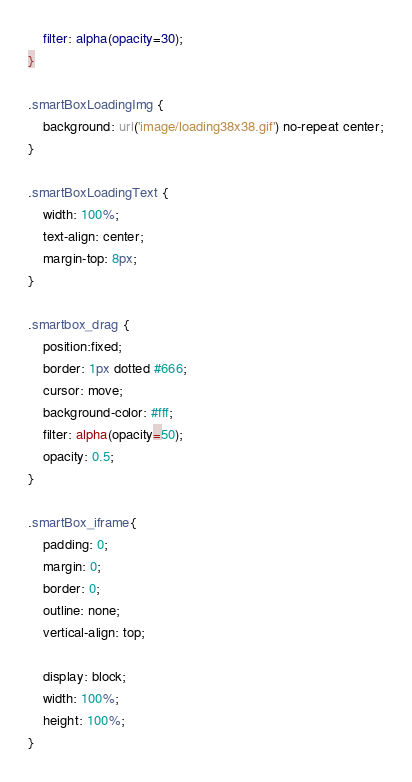<code> <loc_0><loc_0><loc_500><loc_500><_CSS_>    filter: alpha(opacity=30);
}

.smartBoxLoadingImg {
    background: url('image/loading38x38.gif') no-repeat center;
}

.smartBoxLoadingText {
    width: 100%;
    text-align: center;
    margin-top: 8px;
}

.smartbox_drag {
    position:fixed;
    border: 1px dotted #666;
    cursor: move;
    background-color: #fff;
    filter: alpha(opacity=50);
    opacity: 0.5;
}

.smartBox_iframe{
    padding: 0;
    margin: 0;
    border: 0;
    outline: none;
    vertical-align: top;

    display: block;
    width: 100%;
    height: 100%;
}
</code> 